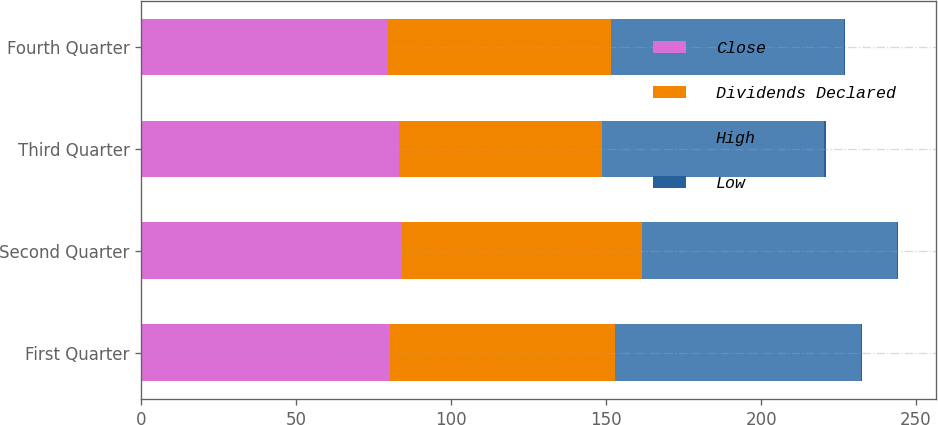Convert chart to OTSL. <chart><loc_0><loc_0><loc_500><loc_500><stacked_bar_chart><ecel><fcel>First Quarter<fcel>Second Quarter<fcel>Third Quarter<fcel>Fourth Quarter<nl><fcel>Close<fcel>80.16<fcel>83.99<fcel>83<fcel>79.72<nl><fcel>Dividends Declared<fcel>72.74<fcel>77.55<fcel>65.5<fcel>71.95<nl><fcel>High<fcel>79.38<fcel>82.33<fcel>71.94<fcel>74.98<nl><fcel>Low<fcel>0.38<fcel>0.38<fcel>0.38<fcel>0.38<nl></chart> 